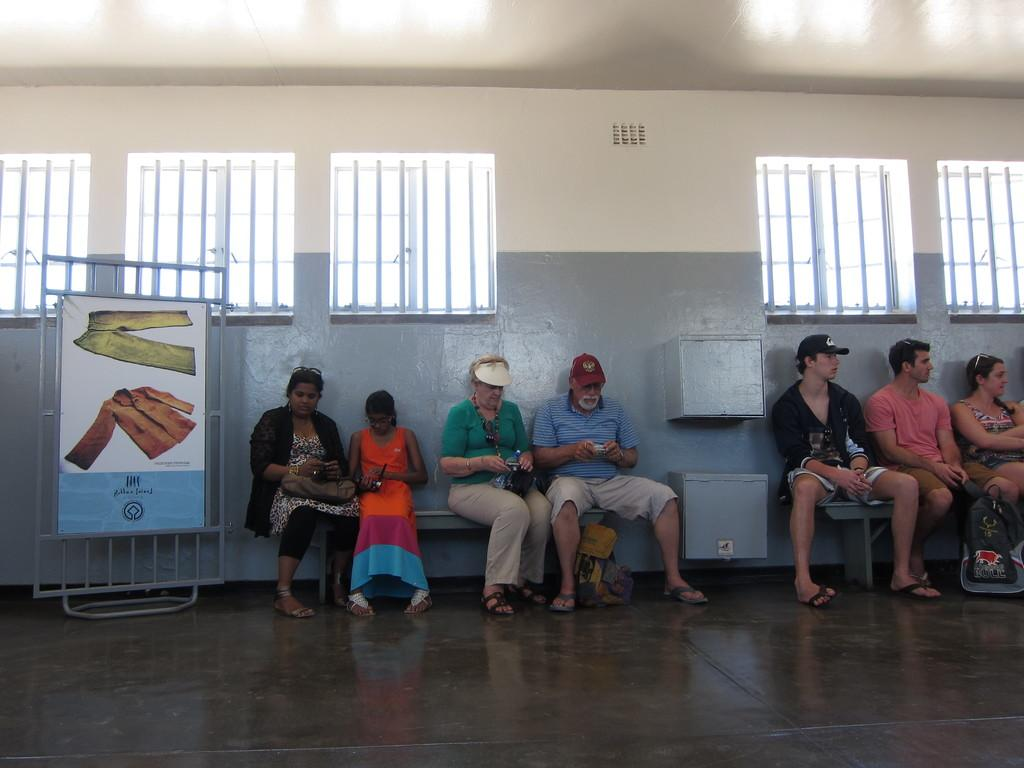What are the people in the image doing? The people in the image are sitting on benches. What can be seen hanging or displayed in the image? There is a banner in the image. What type of structure is visible in the image? There is a wall in the image. What architectural feature can be seen in the wall? There are windows in the image. How many jellyfish are swimming near the people sitting on benches in the image? There are no jellyfish present in the image; it is a land-based scene with no aquatic elements. 